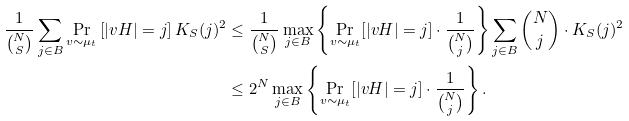Convert formula to latex. <formula><loc_0><loc_0><loc_500><loc_500>\frac { 1 } { \binom { N } { S } } \sum _ { j \in B } \Pr _ { v \sim \mu _ { t } } \left [ | v H | = j \right ] K _ { S } ( j ) ^ { 2 } & \leq \frac { 1 } { \binom { N } { S } } \max _ { j \in B } \left \{ \Pr _ { v \sim \mu _ { t } } [ | v H | = j ] \cdot \frac { 1 } { \binom { N } { j } } \right \} \sum _ { j \in B } \binom { N } { j } \cdot K _ { S } ( j ) ^ { 2 } \\ & \leq 2 ^ { N } \max _ { j \in B } \left \{ \Pr _ { v \sim \mu _ { t } } [ | v H | = j ] \cdot \frac { 1 } { \binom { N } { j } } \right \} .</formula> 